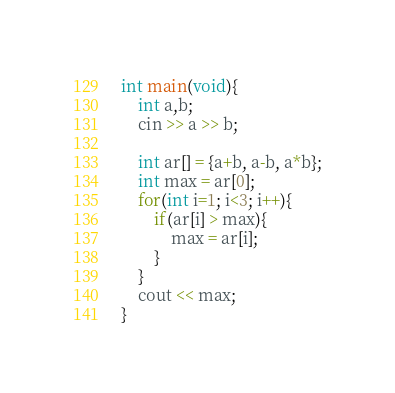<code> <loc_0><loc_0><loc_500><loc_500><_C++_>int main(void){
    int a,b;
    cin >> a >> b;

    int ar[] = {a+b, a-b, a*b};
    int max = ar[0];
    for(int i=1; i<3; i++){
        if(ar[i] > max){
            max = ar[i];
        }
    }
    cout << max;
}</code> 